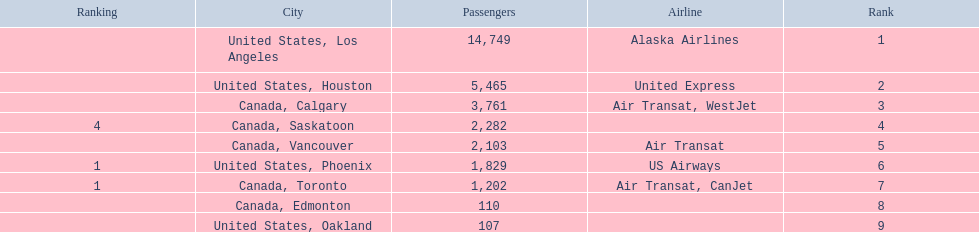What are the cities that are associated with the playa de oro international airport? United States, Los Angeles, United States, Houston, Canada, Calgary, Canada, Saskatoon, Canada, Vancouver, United States, Phoenix, Canada, Toronto, Canada, Edmonton, United States, Oakland. What is uniteed states, los angeles passenger count? 14,749. What other cities passenger count would lead to 19,000 roughly when combined with previous los angeles? Canada, Calgary. 